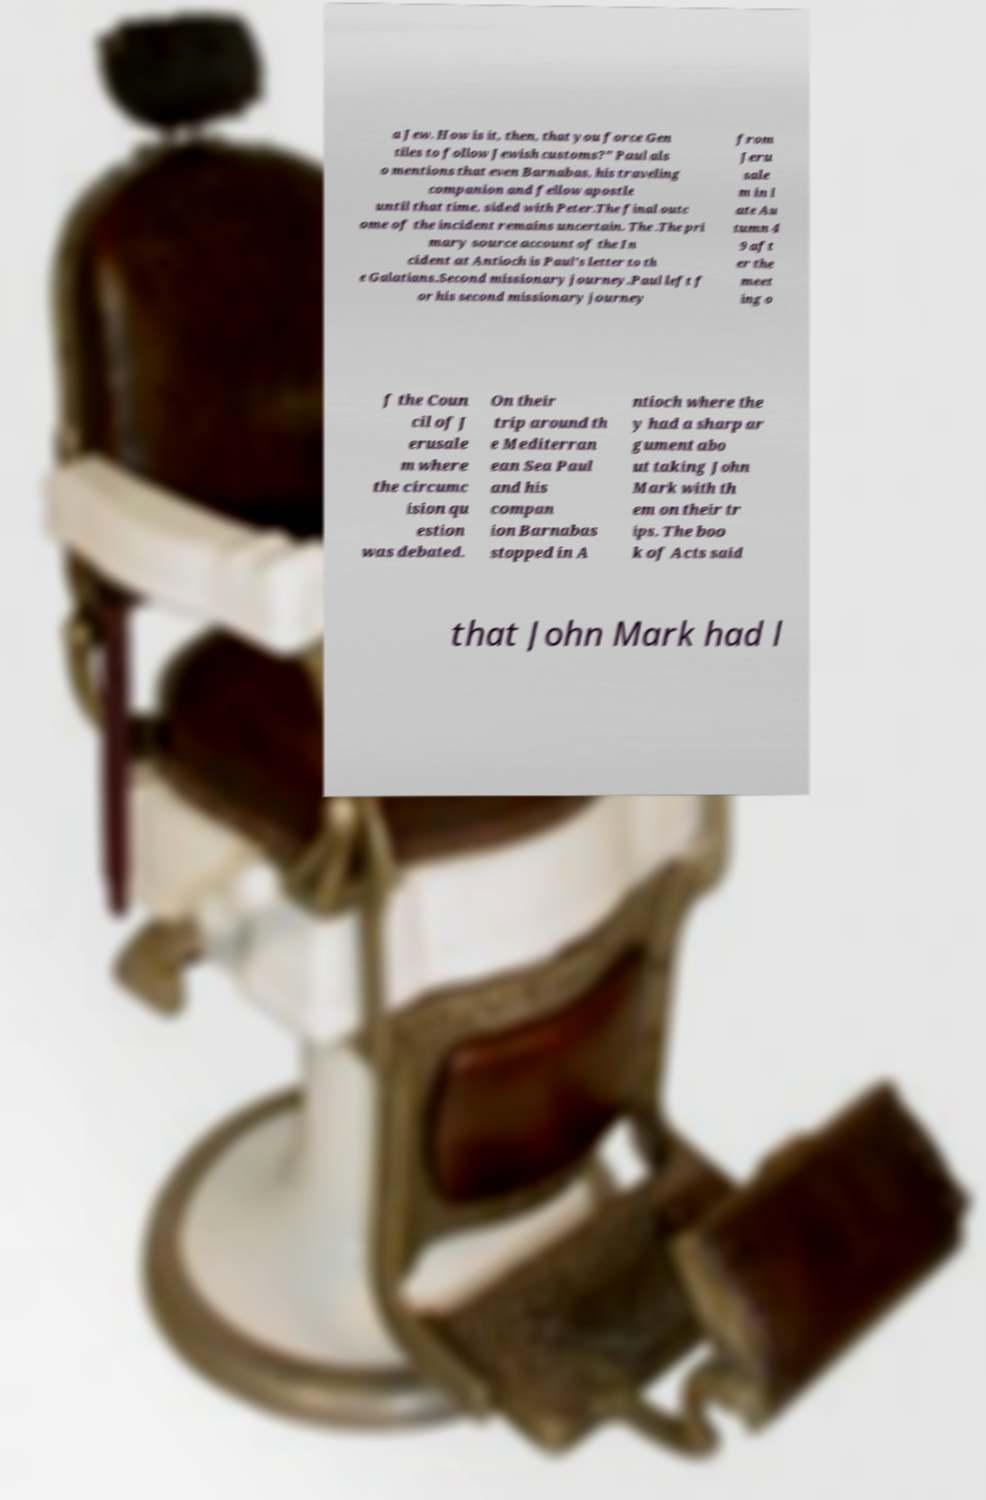I need the written content from this picture converted into text. Can you do that? a Jew. How is it, then, that you force Gen tiles to follow Jewish customs?" Paul als o mentions that even Barnabas, his traveling companion and fellow apostle until that time, sided with Peter.The final outc ome of the incident remains uncertain. The .The pri mary source account of the In cident at Antioch is Paul's letter to th e Galatians.Second missionary journey.Paul left f or his second missionary journey from Jeru sale m in l ate Au tumn 4 9 aft er the meet ing o f the Coun cil of J erusale m where the circumc ision qu estion was debated. On their trip around th e Mediterran ean Sea Paul and his compan ion Barnabas stopped in A ntioch where the y had a sharp ar gument abo ut taking John Mark with th em on their tr ips. The boo k of Acts said that John Mark had l 